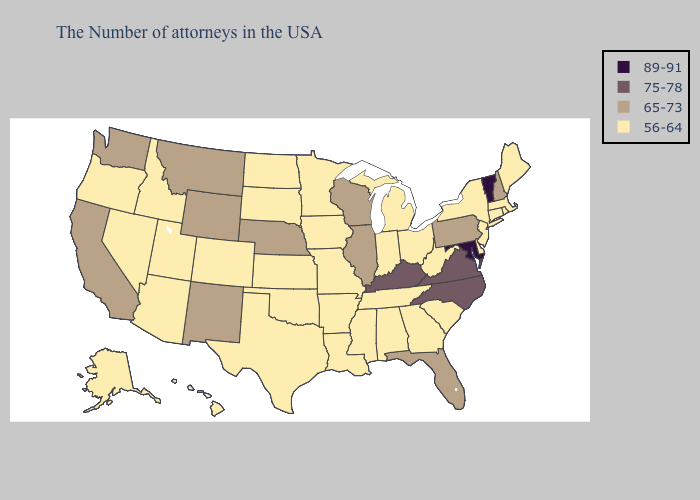What is the highest value in states that border Nevada?
Quick response, please. 65-73. Name the states that have a value in the range 89-91?
Be succinct. Vermont, Maryland. Which states hav the highest value in the Northeast?
Write a very short answer. Vermont. What is the value of Nevada?
Give a very brief answer. 56-64. What is the lowest value in the USA?
Quick response, please. 56-64. Is the legend a continuous bar?
Keep it brief. No. What is the highest value in the USA?
Short answer required. 89-91. Does Vermont have the highest value in the USA?
Write a very short answer. Yes. Name the states that have a value in the range 75-78?
Be succinct. Virginia, North Carolina, Kentucky. Name the states that have a value in the range 75-78?
Quick response, please. Virginia, North Carolina, Kentucky. What is the highest value in the USA?
Write a very short answer. 89-91. What is the highest value in the USA?
Write a very short answer. 89-91. Does Maine have the highest value in the Northeast?
Concise answer only. No. Among the states that border Louisiana , which have the highest value?
Answer briefly. Mississippi, Arkansas, Texas. Does Washington have a lower value than Maryland?
Keep it brief. Yes. 